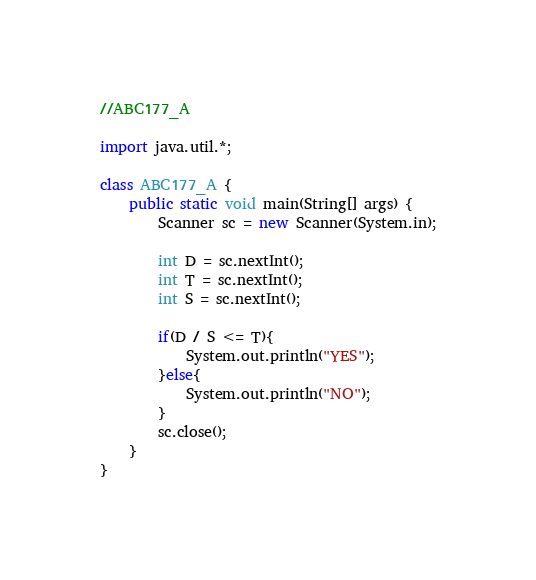Convert code to text. <code><loc_0><loc_0><loc_500><loc_500><_Java_>//ABC177_A

import java.util.*;

class ABC177_A {
	public static void main(String[] args) {
		Scanner sc = new Scanner(System.in);

		int D = sc.nextInt();
		int T = sc.nextInt();
		int S = sc.nextInt();

		if(D / S <= T){
			System.out.println("YES");
		}else{
			System.out.println("NO");
		}
		sc.close();
	}
}</code> 